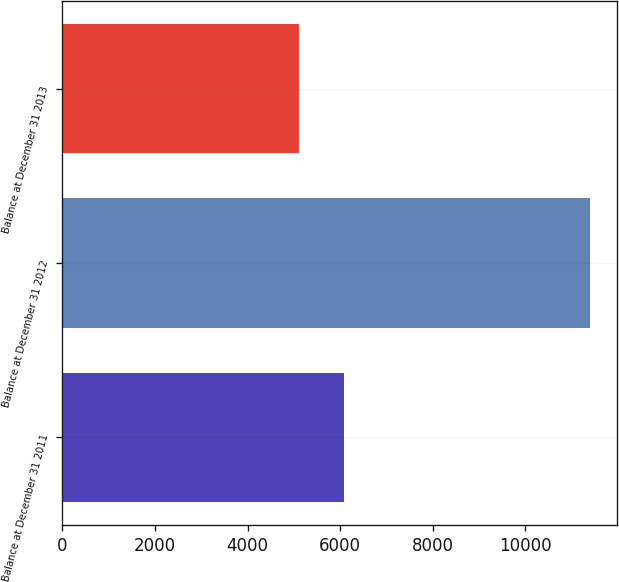Convert chart. <chart><loc_0><loc_0><loc_500><loc_500><bar_chart><fcel>Balance at December 31 2011<fcel>Balance at December 31 2012<fcel>Balance at December 31 2013<nl><fcel>6083<fcel>11397<fcel>5104<nl></chart> 